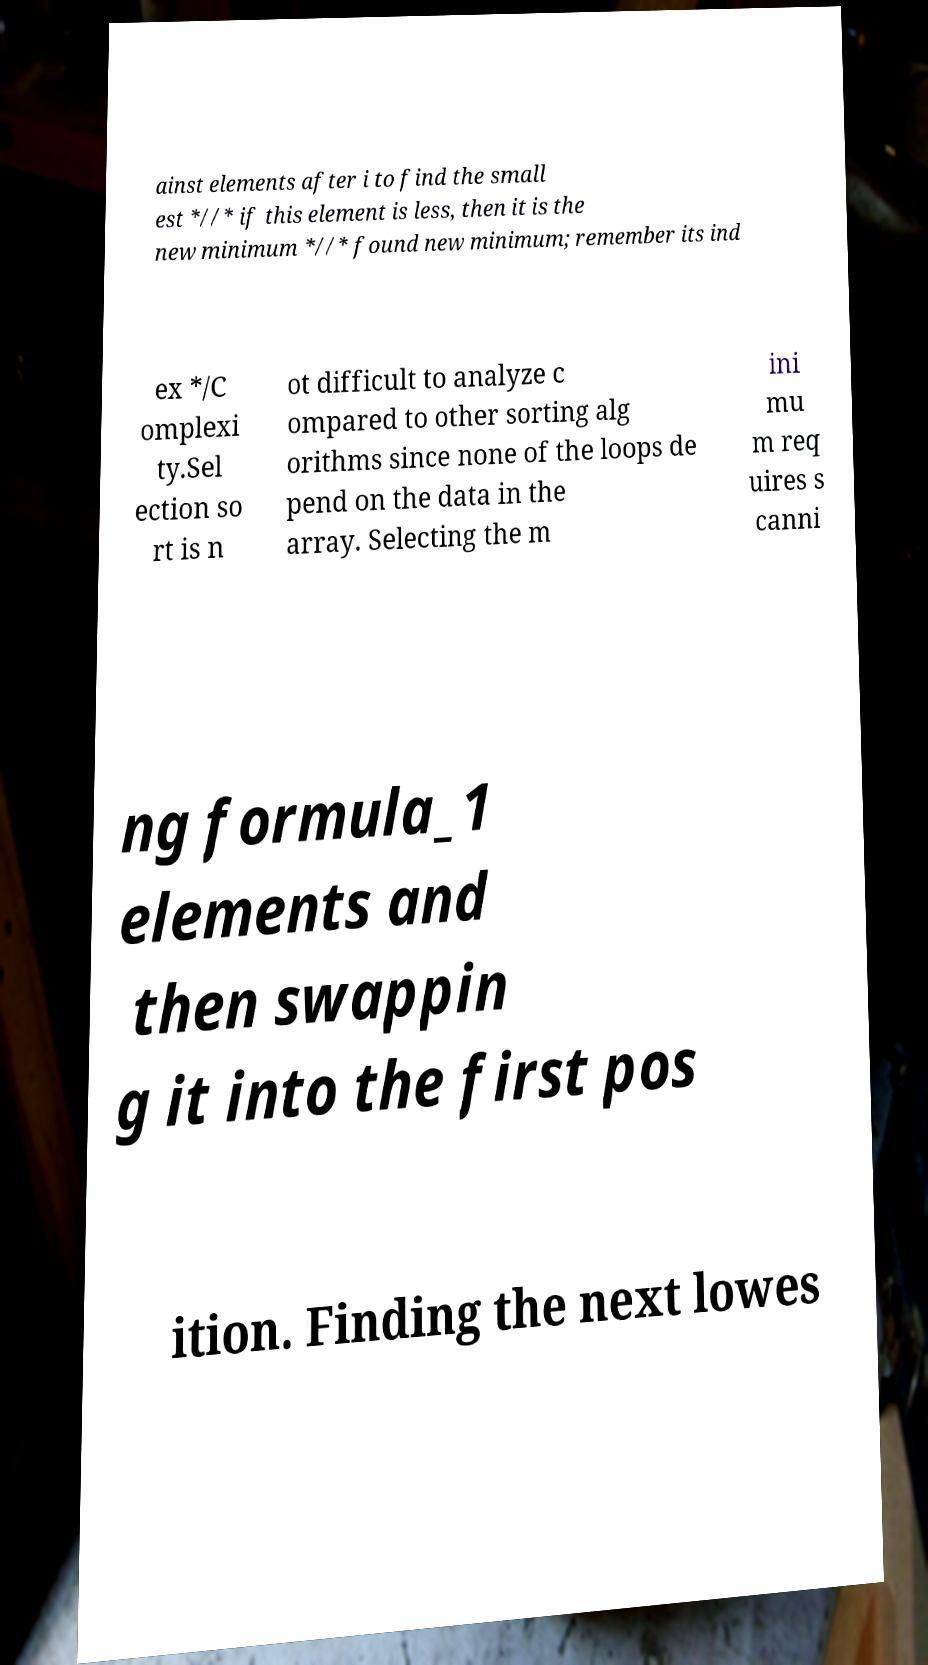For documentation purposes, I need the text within this image transcribed. Could you provide that? ainst elements after i to find the small est *//* if this element is less, then it is the new minimum *//* found new minimum; remember its ind ex */C omplexi ty.Sel ection so rt is n ot difficult to analyze c ompared to other sorting alg orithms since none of the loops de pend on the data in the array. Selecting the m ini mu m req uires s canni ng formula_1 elements and then swappin g it into the first pos ition. Finding the next lowes 